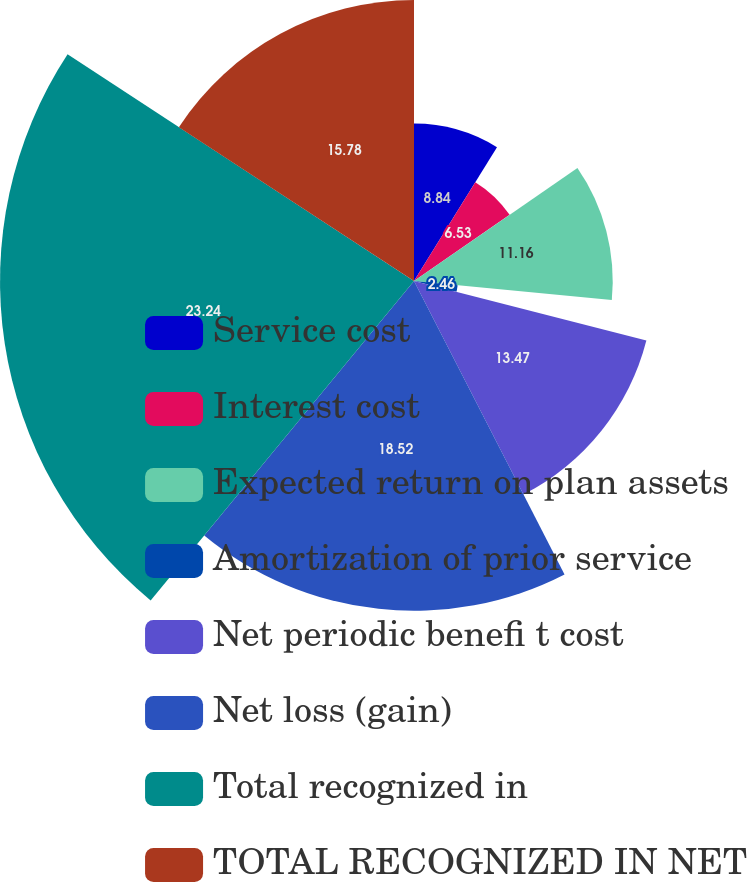Convert chart. <chart><loc_0><loc_0><loc_500><loc_500><pie_chart><fcel>Service cost<fcel>Interest cost<fcel>Expected return on plan assets<fcel>Amortization of prior service<fcel>Net periodic benefi t cost<fcel>Net loss (gain)<fcel>Total recognized in<fcel>TOTAL RECOGNIZED IN NET<nl><fcel>8.84%<fcel>6.53%<fcel>11.16%<fcel>2.46%<fcel>13.47%<fcel>18.52%<fcel>23.25%<fcel>15.78%<nl></chart> 